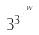Convert formula to latex. <formula><loc_0><loc_0><loc_500><loc_500>3 ^ { 3 ^ { \cdot ^ { \cdot ^ { \cdot ^ { w } } } } }</formula> 